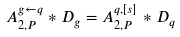<formula> <loc_0><loc_0><loc_500><loc_500>A ^ { g \leftarrow q } _ { 2 , P } \ast D _ { g } = A _ { 2 , P } ^ { q , [ s ] } \ast D _ { q }</formula> 